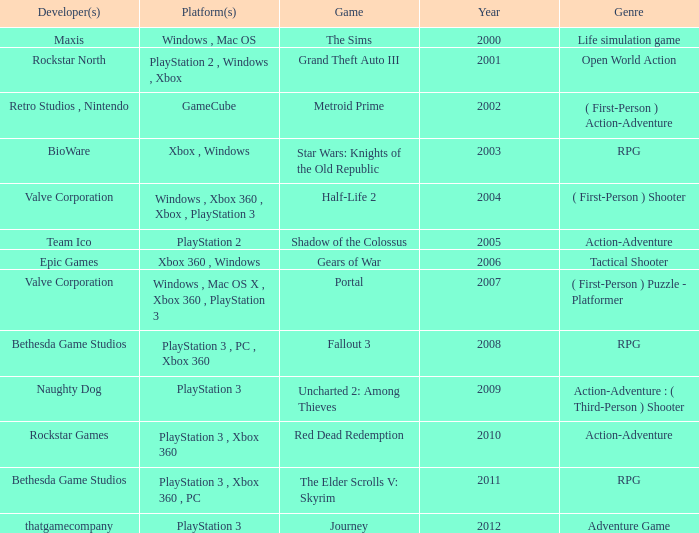What game was in 2005? Shadow of the Colossus. 